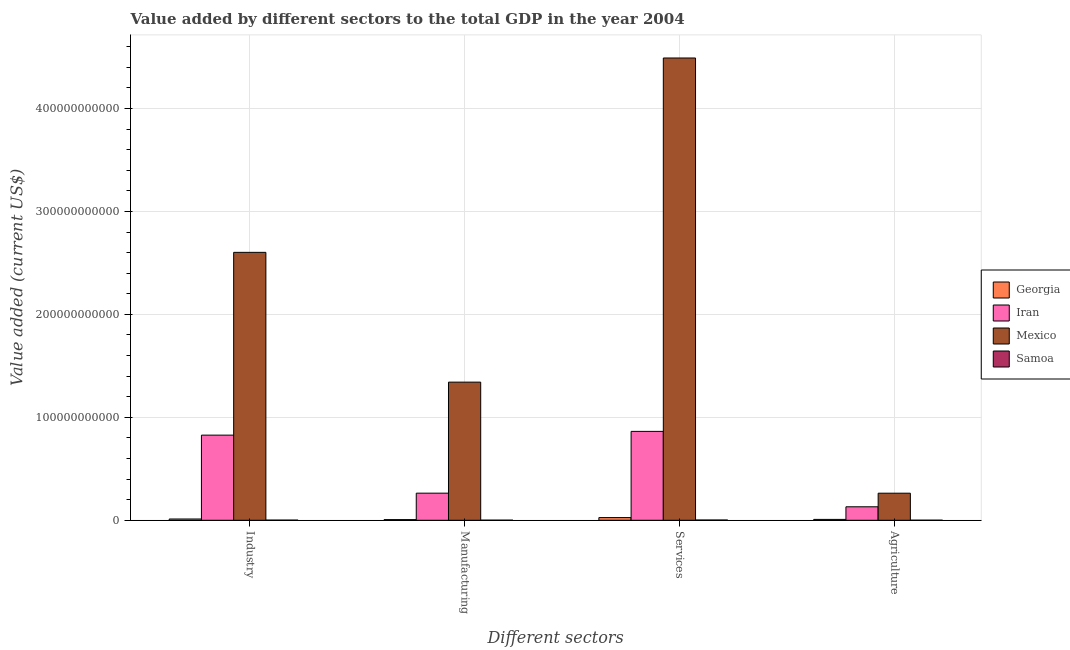How many different coloured bars are there?
Give a very brief answer. 4. How many groups of bars are there?
Give a very brief answer. 4. What is the label of the 3rd group of bars from the left?
Your response must be concise. Services. What is the value added by industrial sector in Georgia?
Offer a very short reply. 1.24e+09. Across all countries, what is the maximum value added by manufacturing sector?
Offer a very short reply. 1.34e+11. Across all countries, what is the minimum value added by industrial sector?
Offer a terse response. 1.23e+08. In which country was the value added by agricultural sector maximum?
Your answer should be very brief. Mexico. In which country was the value added by industrial sector minimum?
Make the answer very short. Samoa. What is the total value added by agricultural sector in the graph?
Your response must be concise. 4.03e+1. What is the difference between the value added by manufacturing sector in Iran and that in Mexico?
Give a very brief answer. -1.08e+11. What is the difference between the value added by industrial sector in Samoa and the value added by services sector in Georgia?
Give a very brief answer. -2.49e+09. What is the average value added by manufacturing sector per country?
Give a very brief answer. 4.03e+1. What is the difference between the value added by services sector and value added by manufacturing sector in Georgia?
Keep it short and to the point. 1.98e+09. What is the ratio of the value added by agricultural sector in Mexico to that in Iran?
Ensure brevity in your answer.  2.01. Is the value added by services sector in Samoa less than that in Georgia?
Provide a short and direct response. Yes. What is the difference between the highest and the second highest value added by manufacturing sector?
Keep it short and to the point. 1.08e+11. What is the difference between the highest and the lowest value added by services sector?
Make the answer very short. 4.49e+11. What does the 1st bar from the left in Agriculture represents?
Offer a terse response. Georgia. What does the 1st bar from the right in Agriculture represents?
Your answer should be very brief. Samoa. Is it the case that in every country, the sum of the value added by industrial sector and value added by manufacturing sector is greater than the value added by services sector?
Give a very brief answer. No. Are all the bars in the graph horizontal?
Offer a very short reply. No. What is the difference between two consecutive major ticks on the Y-axis?
Ensure brevity in your answer.  1.00e+11. Are the values on the major ticks of Y-axis written in scientific E-notation?
Offer a very short reply. No. Does the graph contain any zero values?
Make the answer very short. No. How many legend labels are there?
Your answer should be very brief. 4. How are the legend labels stacked?
Your response must be concise. Vertical. What is the title of the graph?
Your response must be concise. Value added by different sectors to the total GDP in the year 2004. What is the label or title of the X-axis?
Give a very brief answer. Different sectors. What is the label or title of the Y-axis?
Provide a succinct answer. Value added (current US$). What is the Value added (current US$) of Georgia in Industry?
Your answer should be very brief. 1.24e+09. What is the Value added (current US$) in Iran in Industry?
Your answer should be compact. 8.27e+1. What is the Value added (current US$) in Mexico in Industry?
Offer a very short reply. 2.60e+11. What is the Value added (current US$) in Samoa in Industry?
Provide a short and direct response. 1.23e+08. What is the Value added (current US$) in Georgia in Manufacturing?
Your answer should be very brief. 6.26e+08. What is the Value added (current US$) of Iran in Manufacturing?
Ensure brevity in your answer.  2.63e+1. What is the Value added (current US$) in Mexico in Manufacturing?
Provide a short and direct response. 1.34e+11. What is the Value added (current US$) in Samoa in Manufacturing?
Keep it short and to the point. 8.77e+07. What is the Value added (current US$) in Georgia in Services?
Provide a succinct answer. 2.61e+09. What is the Value added (current US$) of Iran in Services?
Ensure brevity in your answer.  8.64e+1. What is the Value added (current US$) in Mexico in Services?
Your answer should be compact. 4.49e+11. What is the Value added (current US$) of Samoa in Services?
Offer a terse response. 2.37e+08. What is the Value added (current US$) of Georgia in Agriculture?
Keep it short and to the point. 8.40e+08. What is the Value added (current US$) in Iran in Agriculture?
Offer a very short reply. 1.31e+1. What is the Value added (current US$) of Mexico in Agriculture?
Offer a very short reply. 2.63e+1. What is the Value added (current US$) in Samoa in Agriculture?
Keep it short and to the point. 5.37e+07. Across all Different sectors, what is the maximum Value added (current US$) in Georgia?
Ensure brevity in your answer.  2.61e+09. Across all Different sectors, what is the maximum Value added (current US$) of Iran?
Your response must be concise. 8.64e+1. Across all Different sectors, what is the maximum Value added (current US$) of Mexico?
Your response must be concise. 4.49e+11. Across all Different sectors, what is the maximum Value added (current US$) in Samoa?
Your answer should be compact. 2.37e+08. Across all Different sectors, what is the minimum Value added (current US$) in Georgia?
Your answer should be very brief. 6.26e+08. Across all Different sectors, what is the minimum Value added (current US$) of Iran?
Your answer should be compact. 1.31e+1. Across all Different sectors, what is the minimum Value added (current US$) of Mexico?
Give a very brief answer. 2.63e+1. Across all Different sectors, what is the minimum Value added (current US$) in Samoa?
Provide a short and direct response. 5.37e+07. What is the total Value added (current US$) of Georgia in the graph?
Provide a short and direct response. 5.32e+09. What is the total Value added (current US$) of Iran in the graph?
Ensure brevity in your answer.  2.08e+11. What is the total Value added (current US$) of Mexico in the graph?
Provide a short and direct response. 8.70e+11. What is the total Value added (current US$) of Samoa in the graph?
Provide a succinct answer. 5.01e+08. What is the difference between the Value added (current US$) in Georgia in Industry and that in Manufacturing?
Offer a very short reply. 6.13e+08. What is the difference between the Value added (current US$) in Iran in Industry and that in Manufacturing?
Ensure brevity in your answer.  5.64e+1. What is the difference between the Value added (current US$) in Mexico in Industry and that in Manufacturing?
Offer a terse response. 1.26e+11. What is the difference between the Value added (current US$) of Samoa in Industry and that in Manufacturing?
Offer a very short reply. 3.51e+07. What is the difference between the Value added (current US$) in Georgia in Industry and that in Services?
Give a very brief answer. -1.37e+09. What is the difference between the Value added (current US$) of Iran in Industry and that in Services?
Keep it short and to the point. -3.65e+09. What is the difference between the Value added (current US$) in Mexico in Industry and that in Services?
Give a very brief answer. -1.89e+11. What is the difference between the Value added (current US$) in Samoa in Industry and that in Services?
Provide a short and direct response. -1.14e+08. What is the difference between the Value added (current US$) in Georgia in Industry and that in Agriculture?
Provide a short and direct response. 3.99e+08. What is the difference between the Value added (current US$) of Iran in Industry and that in Agriculture?
Ensure brevity in your answer.  6.96e+1. What is the difference between the Value added (current US$) of Mexico in Industry and that in Agriculture?
Give a very brief answer. 2.34e+11. What is the difference between the Value added (current US$) in Samoa in Industry and that in Agriculture?
Keep it short and to the point. 6.91e+07. What is the difference between the Value added (current US$) of Georgia in Manufacturing and that in Services?
Make the answer very short. -1.98e+09. What is the difference between the Value added (current US$) in Iran in Manufacturing and that in Services?
Your answer should be very brief. -6.00e+1. What is the difference between the Value added (current US$) of Mexico in Manufacturing and that in Services?
Keep it short and to the point. -3.15e+11. What is the difference between the Value added (current US$) in Samoa in Manufacturing and that in Services?
Your answer should be compact. -1.49e+08. What is the difference between the Value added (current US$) of Georgia in Manufacturing and that in Agriculture?
Provide a succinct answer. -2.14e+08. What is the difference between the Value added (current US$) in Iran in Manufacturing and that in Agriculture?
Provide a succinct answer. 1.32e+1. What is the difference between the Value added (current US$) of Mexico in Manufacturing and that in Agriculture?
Offer a terse response. 1.08e+11. What is the difference between the Value added (current US$) in Samoa in Manufacturing and that in Agriculture?
Provide a succinct answer. 3.40e+07. What is the difference between the Value added (current US$) in Georgia in Services and that in Agriculture?
Your response must be concise. 1.77e+09. What is the difference between the Value added (current US$) in Iran in Services and that in Agriculture?
Offer a very short reply. 7.33e+1. What is the difference between the Value added (current US$) of Mexico in Services and that in Agriculture?
Your answer should be very brief. 4.23e+11. What is the difference between the Value added (current US$) of Samoa in Services and that in Agriculture?
Your response must be concise. 1.83e+08. What is the difference between the Value added (current US$) in Georgia in Industry and the Value added (current US$) in Iran in Manufacturing?
Your answer should be very brief. -2.51e+1. What is the difference between the Value added (current US$) of Georgia in Industry and the Value added (current US$) of Mexico in Manufacturing?
Keep it short and to the point. -1.33e+11. What is the difference between the Value added (current US$) of Georgia in Industry and the Value added (current US$) of Samoa in Manufacturing?
Your response must be concise. 1.15e+09. What is the difference between the Value added (current US$) of Iran in Industry and the Value added (current US$) of Mexico in Manufacturing?
Provide a short and direct response. -5.15e+1. What is the difference between the Value added (current US$) of Iran in Industry and the Value added (current US$) of Samoa in Manufacturing?
Provide a short and direct response. 8.26e+1. What is the difference between the Value added (current US$) of Mexico in Industry and the Value added (current US$) of Samoa in Manufacturing?
Provide a succinct answer. 2.60e+11. What is the difference between the Value added (current US$) in Georgia in Industry and the Value added (current US$) in Iran in Services?
Your answer should be compact. -8.51e+1. What is the difference between the Value added (current US$) of Georgia in Industry and the Value added (current US$) of Mexico in Services?
Provide a short and direct response. -4.48e+11. What is the difference between the Value added (current US$) in Georgia in Industry and the Value added (current US$) in Samoa in Services?
Ensure brevity in your answer.  1.00e+09. What is the difference between the Value added (current US$) in Iran in Industry and the Value added (current US$) in Mexico in Services?
Offer a very short reply. -3.66e+11. What is the difference between the Value added (current US$) of Iran in Industry and the Value added (current US$) of Samoa in Services?
Offer a terse response. 8.25e+1. What is the difference between the Value added (current US$) in Mexico in Industry and the Value added (current US$) in Samoa in Services?
Make the answer very short. 2.60e+11. What is the difference between the Value added (current US$) of Georgia in Industry and the Value added (current US$) of Iran in Agriculture?
Ensure brevity in your answer.  -1.19e+1. What is the difference between the Value added (current US$) of Georgia in Industry and the Value added (current US$) of Mexico in Agriculture?
Make the answer very short. -2.51e+1. What is the difference between the Value added (current US$) in Georgia in Industry and the Value added (current US$) in Samoa in Agriculture?
Keep it short and to the point. 1.19e+09. What is the difference between the Value added (current US$) of Iran in Industry and the Value added (current US$) of Mexico in Agriculture?
Offer a very short reply. 5.64e+1. What is the difference between the Value added (current US$) in Iran in Industry and the Value added (current US$) in Samoa in Agriculture?
Your response must be concise. 8.26e+1. What is the difference between the Value added (current US$) of Mexico in Industry and the Value added (current US$) of Samoa in Agriculture?
Provide a short and direct response. 2.60e+11. What is the difference between the Value added (current US$) of Georgia in Manufacturing and the Value added (current US$) of Iran in Services?
Offer a terse response. -8.57e+1. What is the difference between the Value added (current US$) in Georgia in Manufacturing and the Value added (current US$) in Mexico in Services?
Give a very brief answer. -4.48e+11. What is the difference between the Value added (current US$) in Georgia in Manufacturing and the Value added (current US$) in Samoa in Services?
Offer a terse response. 3.90e+08. What is the difference between the Value added (current US$) in Iran in Manufacturing and the Value added (current US$) in Mexico in Services?
Offer a very short reply. -4.23e+11. What is the difference between the Value added (current US$) in Iran in Manufacturing and the Value added (current US$) in Samoa in Services?
Offer a very short reply. 2.61e+1. What is the difference between the Value added (current US$) in Mexico in Manufacturing and the Value added (current US$) in Samoa in Services?
Your response must be concise. 1.34e+11. What is the difference between the Value added (current US$) in Georgia in Manufacturing and the Value added (current US$) in Iran in Agriculture?
Keep it short and to the point. -1.25e+1. What is the difference between the Value added (current US$) of Georgia in Manufacturing and the Value added (current US$) of Mexico in Agriculture?
Provide a succinct answer. -2.57e+1. What is the difference between the Value added (current US$) in Georgia in Manufacturing and the Value added (current US$) in Samoa in Agriculture?
Provide a succinct answer. 5.73e+08. What is the difference between the Value added (current US$) in Iran in Manufacturing and the Value added (current US$) in Mexico in Agriculture?
Offer a terse response. 3.09e+07. What is the difference between the Value added (current US$) of Iran in Manufacturing and the Value added (current US$) of Samoa in Agriculture?
Provide a short and direct response. 2.63e+1. What is the difference between the Value added (current US$) in Mexico in Manufacturing and the Value added (current US$) in Samoa in Agriculture?
Offer a very short reply. 1.34e+11. What is the difference between the Value added (current US$) in Georgia in Services and the Value added (current US$) in Iran in Agriculture?
Ensure brevity in your answer.  -1.05e+1. What is the difference between the Value added (current US$) in Georgia in Services and the Value added (current US$) in Mexico in Agriculture?
Give a very brief answer. -2.37e+1. What is the difference between the Value added (current US$) of Georgia in Services and the Value added (current US$) of Samoa in Agriculture?
Keep it short and to the point. 2.56e+09. What is the difference between the Value added (current US$) in Iran in Services and the Value added (current US$) in Mexico in Agriculture?
Keep it short and to the point. 6.01e+1. What is the difference between the Value added (current US$) of Iran in Services and the Value added (current US$) of Samoa in Agriculture?
Provide a succinct answer. 8.63e+1. What is the difference between the Value added (current US$) of Mexico in Services and the Value added (current US$) of Samoa in Agriculture?
Give a very brief answer. 4.49e+11. What is the average Value added (current US$) in Georgia per Different sectors?
Provide a short and direct response. 1.33e+09. What is the average Value added (current US$) in Iran per Different sectors?
Offer a terse response. 5.21e+1. What is the average Value added (current US$) in Mexico per Different sectors?
Offer a very short reply. 2.17e+11. What is the average Value added (current US$) of Samoa per Different sectors?
Provide a succinct answer. 1.25e+08. What is the difference between the Value added (current US$) in Georgia and Value added (current US$) in Iran in Industry?
Offer a very short reply. -8.15e+1. What is the difference between the Value added (current US$) of Georgia and Value added (current US$) of Mexico in Industry?
Ensure brevity in your answer.  -2.59e+11. What is the difference between the Value added (current US$) in Georgia and Value added (current US$) in Samoa in Industry?
Give a very brief answer. 1.12e+09. What is the difference between the Value added (current US$) in Iran and Value added (current US$) in Mexico in Industry?
Make the answer very short. -1.78e+11. What is the difference between the Value added (current US$) in Iran and Value added (current US$) in Samoa in Industry?
Give a very brief answer. 8.26e+1. What is the difference between the Value added (current US$) of Mexico and Value added (current US$) of Samoa in Industry?
Your answer should be very brief. 2.60e+11. What is the difference between the Value added (current US$) in Georgia and Value added (current US$) in Iran in Manufacturing?
Your answer should be compact. -2.57e+1. What is the difference between the Value added (current US$) of Georgia and Value added (current US$) of Mexico in Manufacturing?
Offer a terse response. -1.34e+11. What is the difference between the Value added (current US$) in Georgia and Value added (current US$) in Samoa in Manufacturing?
Your response must be concise. 5.39e+08. What is the difference between the Value added (current US$) in Iran and Value added (current US$) in Mexico in Manufacturing?
Provide a succinct answer. -1.08e+11. What is the difference between the Value added (current US$) in Iran and Value added (current US$) in Samoa in Manufacturing?
Provide a succinct answer. 2.62e+1. What is the difference between the Value added (current US$) of Mexico and Value added (current US$) of Samoa in Manufacturing?
Provide a succinct answer. 1.34e+11. What is the difference between the Value added (current US$) of Georgia and Value added (current US$) of Iran in Services?
Make the answer very short. -8.37e+1. What is the difference between the Value added (current US$) of Georgia and Value added (current US$) of Mexico in Services?
Provide a short and direct response. -4.46e+11. What is the difference between the Value added (current US$) in Georgia and Value added (current US$) in Samoa in Services?
Offer a terse response. 2.37e+09. What is the difference between the Value added (current US$) in Iran and Value added (current US$) in Mexico in Services?
Keep it short and to the point. -3.63e+11. What is the difference between the Value added (current US$) in Iran and Value added (current US$) in Samoa in Services?
Offer a terse response. 8.61e+1. What is the difference between the Value added (current US$) of Mexico and Value added (current US$) of Samoa in Services?
Make the answer very short. 4.49e+11. What is the difference between the Value added (current US$) in Georgia and Value added (current US$) in Iran in Agriculture?
Your answer should be compact. -1.23e+1. What is the difference between the Value added (current US$) of Georgia and Value added (current US$) of Mexico in Agriculture?
Offer a terse response. -2.55e+1. What is the difference between the Value added (current US$) in Georgia and Value added (current US$) in Samoa in Agriculture?
Provide a succinct answer. 7.87e+08. What is the difference between the Value added (current US$) of Iran and Value added (current US$) of Mexico in Agriculture?
Your answer should be compact. -1.32e+1. What is the difference between the Value added (current US$) of Iran and Value added (current US$) of Samoa in Agriculture?
Offer a very short reply. 1.30e+1. What is the difference between the Value added (current US$) of Mexico and Value added (current US$) of Samoa in Agriculture?
Provide a short and direct response. 2.62e+1. What is the ratio of the Value added (current US$) in Georgia in Industry to that in Manufacturing?
Give a very brief answer. 1.98. What is the ratio of the Value added (current US$) in Iran in Industry to that in Manufacturing?
Provide a short and direct response. 3.14. What is the ratio of the Value added (current US$) in Mexico in Industry to that in Manufacturing?
Offer a terse response. 1.94. What is the ratio of the Value added (current US$) of Samoa in Industry to that in Manufacturing?
Provide a short and direct response. 1.4. What is the ratio of the Value added (current US$) in Georgia in Industry to that in Services?
Your answer should be compact. 0.47. What is the ratio of the Value added (current US$) of Iran in Industry to that in Services?
Ensure brevity in your answer.  0.96. What is the ratio of the Value added (current US$) in Mexico in Industry to that in Services?
Offer a terse response. 0.58. What is the ratio of the Value added (current US$) in Samoa in Industry to that in Services?
Provide a succinct answer. 0.52. What is the ratio of the Value added (current US$) of Georgia in Industry to that in Agriculture?
Your response must be concise. 1.47. What is the ratio of the Value added (current US$) in Iran in Industry to that in Agriculture?
Offer a very short reply. 6.32. What is the ratio of the Value added (current US$) in Mexico in Industry to that in Agriculture?
Your answer should be very brief. 9.9. What is the ratio of the Value added (current US$) of Samoa in Industry to that in Agriculture?
Provide a short and direct response. 2.29. What is the ratio of the Value added (current US$) in Georgia in Manufacturing to that in Services?
Provide a succinct answer. 0.24. What is the ratio of the Value added (current US$) of Iran in Manufacturing to that in Services?
Provide a succinct answer. 0.3. What is the ratio of the Value added (current US$) of Mexico in Manufacturing to that in Services?
Ensure brevity in your answer.  0.3. What is the ratio of the Value added (current US$) of Samoa in Manufacturing to that in Services?
Make the answer very short. 0.37. What is the ratio of the Value added (current US$) of Georgia in Manufacturing to that in Agriculture?
Give a very brief answer. 0.75. What is the ratio of the Value added (current US$) in Iran in Manufacturing to that in Agriculture?
Make the answer very short. 2.01. What is the ratio of the Value added (current US$) in Mexico in Manufacturing to that in Agriculture?
Your answer should be very brief. 5.1. What is the ratio of the Value added (current US$) of Samoa in Manufacturing to that in Agriculture?
Make the answer very short. 1.63. What is the ratio of the Value added (current US$) of Georgia in Services to that in Agriculture?
Offer a very short reply. 3.11. What is the ratio of the Value added (current US$) in Iran in Services to that in Agriculture?
Offer a terse response. 6.59. What is the ratio of the Value added (current US$) in Mexico in Services to that in Agriculture?
Give a very brief answer. 17.07. What is the ratio of the Value added (current US$) of Samoa in Services to that in Agriculture?
Your response must be concise. 4.41. What is the difference between the highest and the second highest Value added (current US$) of Georgia?
Provide a short and direct response. 1.37e+09. What is the difference between the highest and the second highest Value added (current US$) in Iran?
Provide a succinct answer. 3.65e+09. What is the difference between the highest and the second highest Value added (current US$) of Mexico?
Keep it short and to the point. 1.89e+11. What is the difference between the highest and the second highest Value added (current US$) in Samoa?
Your answer should be very brief. 1.14e+08. What is the difference between the highest and the lowest Value added (current US$) of Georgia?
Ensure brevity in your answer.  1.98e+09. What is the difference between the highest and the lowest Value added (current US$) of Iran?
Provide a short and direct response. 7.33e+1. What is the difference between the highest and the lowest Value added (current US$) of Mexico?
Offer a very short reply. 4.23e+11. What is the difference between the highest and the lowest Value added (current US$) in Samoa?
Provide a short and direct response. 1.83e+08. 